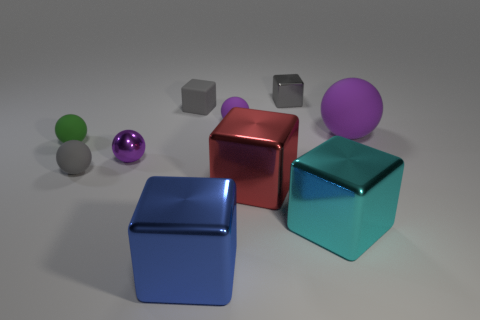Are there any purple rubber spheres behind the purple shiny object to the right of the tiny matte ball that is on the left side of the small gray sphere? Yes, there is one purple rubber sphere located behind the purple shiny object. To provide a more detailed description, the sphere is positioned directly in the back of the larger purple shiny sphere to the right when facing the set of objects. This position is in reference to a tiny matte ball that is situated on the left side of a small gray sphere in the foreground of the image. 